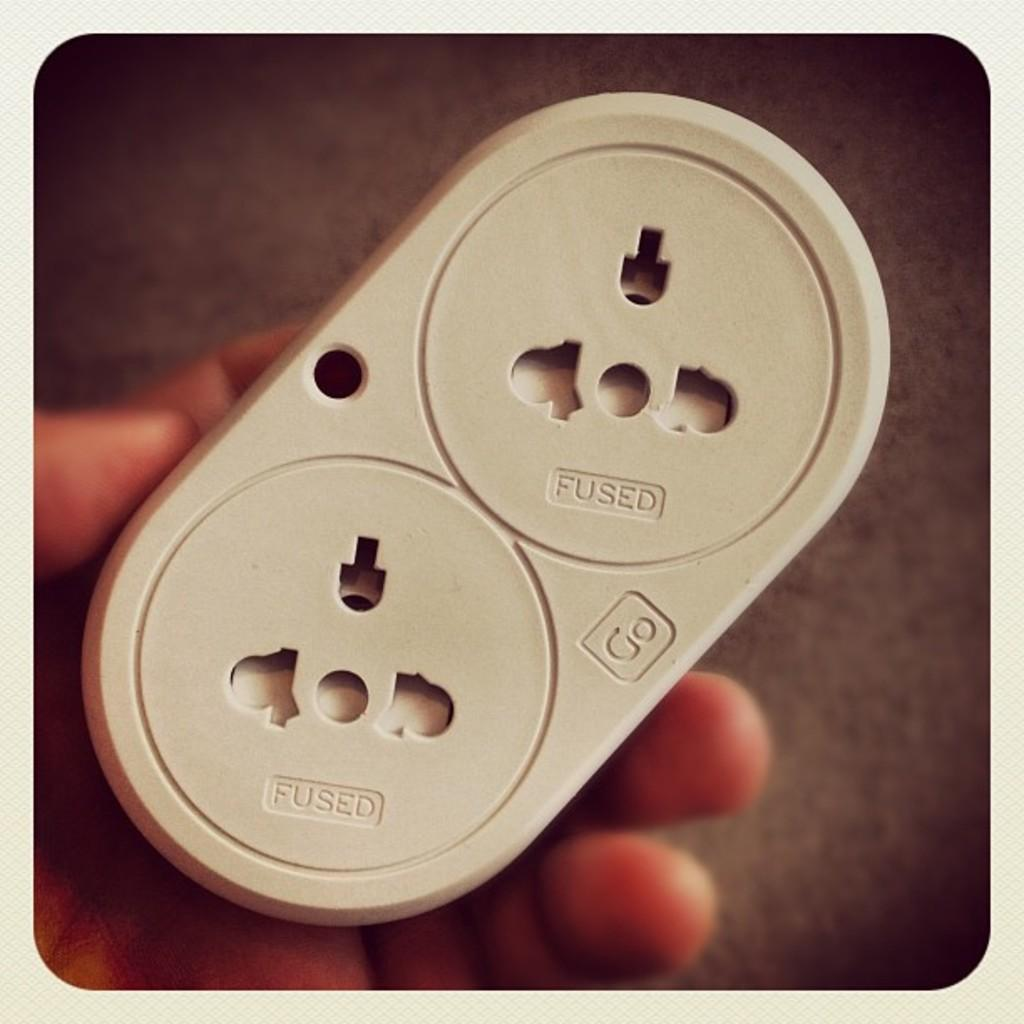<image>
Describe the image concisely. A hand holds a device that says Fused and Go on it. 